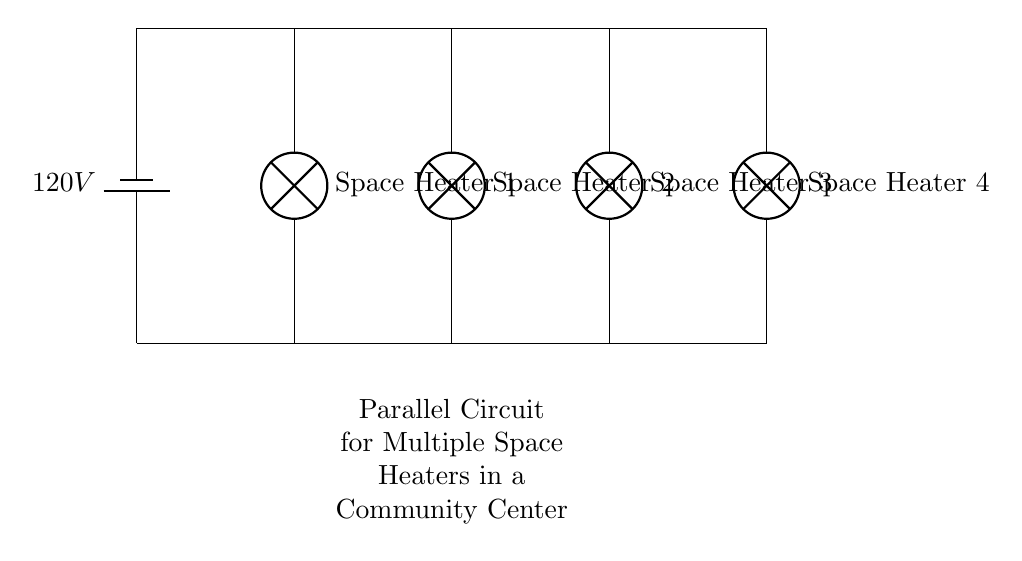What is the total number of space heaters in the circuit? The circuit diagram shows four lamps, each representing a space heater, connected in parallel. Therefore, the total count is simply the number of lamps.
Answer: Four What is the voltage supplied to the circuit? The drawing indicates a battery with a label of 120 volts, which represents the voltage supplied to the entire circuit.
Answer: 120 volts How are the space heaters connected in the circuit? The diagram shows that each space heater is connected directly to the voltage supply in parallel, meaning each has its own separate path to the same voltage source. This allows them to operate independently.
Answer: In parallel If one space heater fails, what happens to the others? In a parallel circuit, if one component fails (like one of the space heaters), the others remain operational because each has its own independent path to the voltage source. This resilience is a key feature of parallel circuits.
Answer: They remain operational What type of circuit is used for the space heaters? The circuit can be identified by the arrangement of the components, where all heaters are connected across the same two points of potential, which is characteristic of a parallel circuit.
Answer: Parallel What is the purpose of using a parallel circuit for the space heaters? The main advantage of a parallel configuration for space heaters is the ability to provide the same voltage to all heaters while allowing each to function independently, thus enhancing safety and flexibility for the users.
Answer: To ensure independent operation 